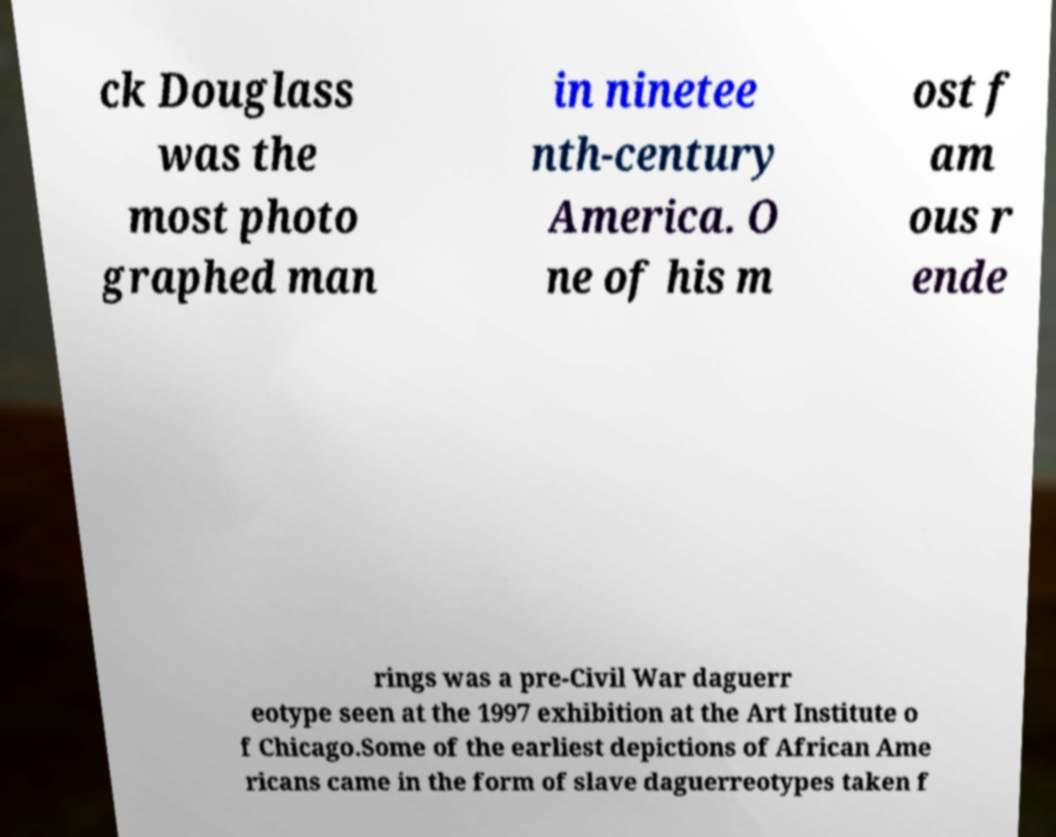I need the written content from this picture converted into text. Can you do that? ck Douglass was the most photo graphed man in ninetee nth-century America. O ne of his m ost f am ous r ende rings was a pre-Civil War daguerr eotype seen at the 1997 exhibition at the Art Institute o f Chicago.Some of the earliest depictions of African Ame ricans came in the form of slave daguerreotypes taken f 